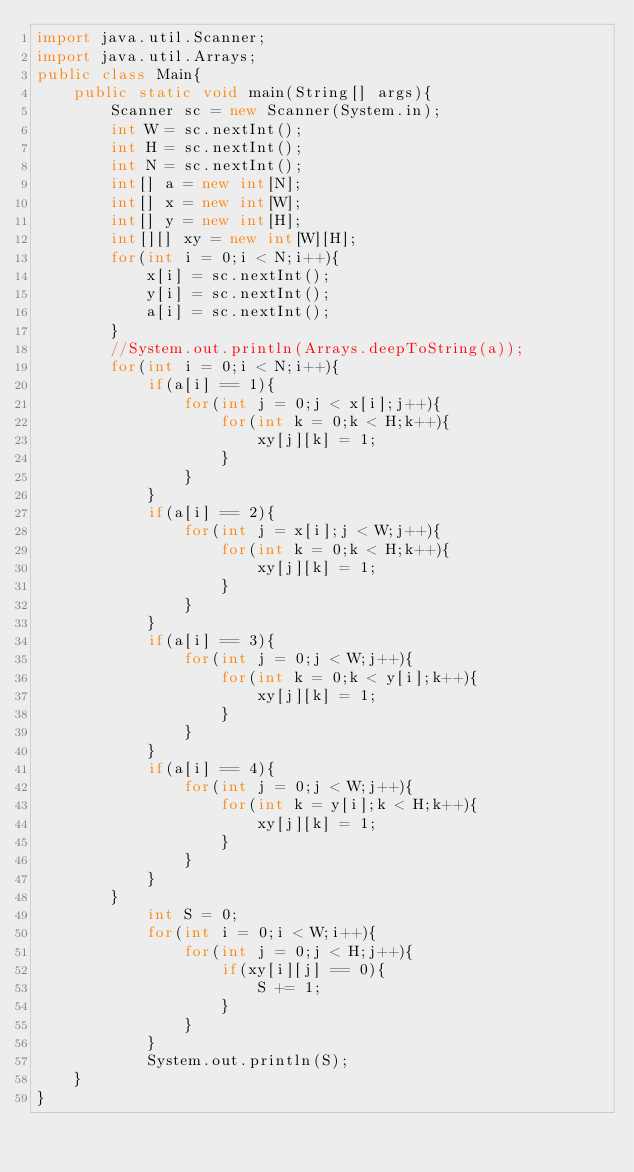<code> <loc_0><loc_0><loc_500><loc_500><_Java_>import java.util.Scanner;
import java.util.Arrays;
public class Main{
    public static void main(String[] args){
        Scanner sc = new Scanner(System.in);
        int W = sc.nextInt();
        int H = sc.nextInt();
        int N = sc.nextInt();
        int[] a = new int[N];
        int[] x = new int[W];
        int[] y = new int[H];
        int[][] xy = new int[W][H];
        for(int i = 0;i < N;i++){
            x[i] = sc.nextInt();
            y[i] = sc.nextInt();
            a[i] = sc.nextInt();
        }
        //System.out.println(Arrays.deepToString(a));
        for(int i = 0;i < N;i++){
            if(a[i] == 1){
                for(int j = 0;j < x[i];j++){
                    for(int k = 0;k < H;k++){
                        xy[j][k] = 1;
                    }
                }
            }
            if(a[i] == 2){
                for(int j = x[i];j < W;j++){
                    for(int k = 0;k < H;k++){
                        xy[j][k] = 1;
                    }
                }
            }
            if(a[i] == 3){
                for(int j = 0;j < W;j++){
                    for(int k = 0;k < y[i];k++){
                        xy[j][k] = 1;
                    }
                }
            }
            if(a[i] == 4){
                for(int j = 0;j < W;j++){
                    for(int k = y[i];k < H;k++){
                        xy[j][k] = 1;
                    }
                }
            }
        }
            int S = 0;
            for(int i = 0;i < W;i++){
                for(int j = 0;j < H;j++){
                    if(xy[i][j] == 0){
                        S += 1;
                    }
                }
            }
            System.out.println(S);
    }
}
</code> 